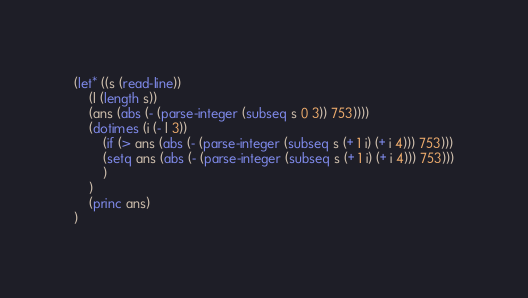Convert code to text. <code><loc_0><loc_0><loc_500><loc_500><_Lisp_>(let* ((s (read-line))
    (l (length s))
    (ans (abs (- (parse-integer (subseq s 0 3)) 753))))
    (dotimes (i (- l 3))
        (if (> ans (abs (- (parse-integer (subseq s (+ 1 i) (+ i 4))) 753)))
        (setq ans (abs (- (parse-integer (subseq s (+ 1 i) (+ i 4))) 753)))
        )
    )
    (princ ans)
)</code> 